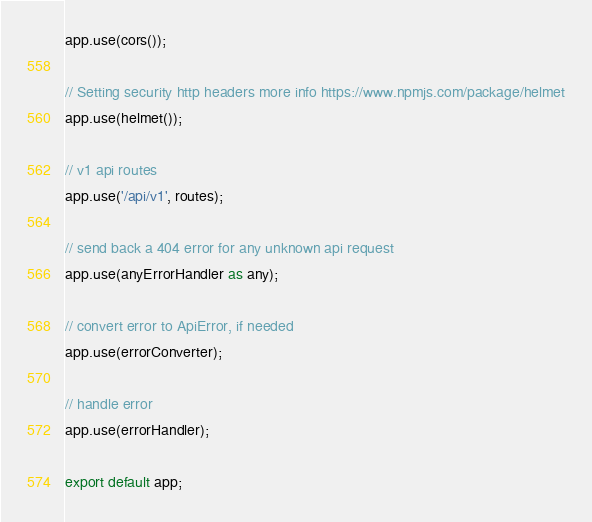<code> <loc_0><loc_0><loc_500><loc_500><_TypeScript_>app.use(cors());

// Setting security http headers more info https://www.npmjs.com/package/helmet
app.use(helmet());

// v1 api routes
app.use('/api/v1', routes);

// send back a 404 error for any unknown api request
app.use(anyErrorHandler as any);

// convert error to ApiError, if needed
app.use(errorConverter);

// handle error
app.use(errorHandler);

export default app;
</code> 